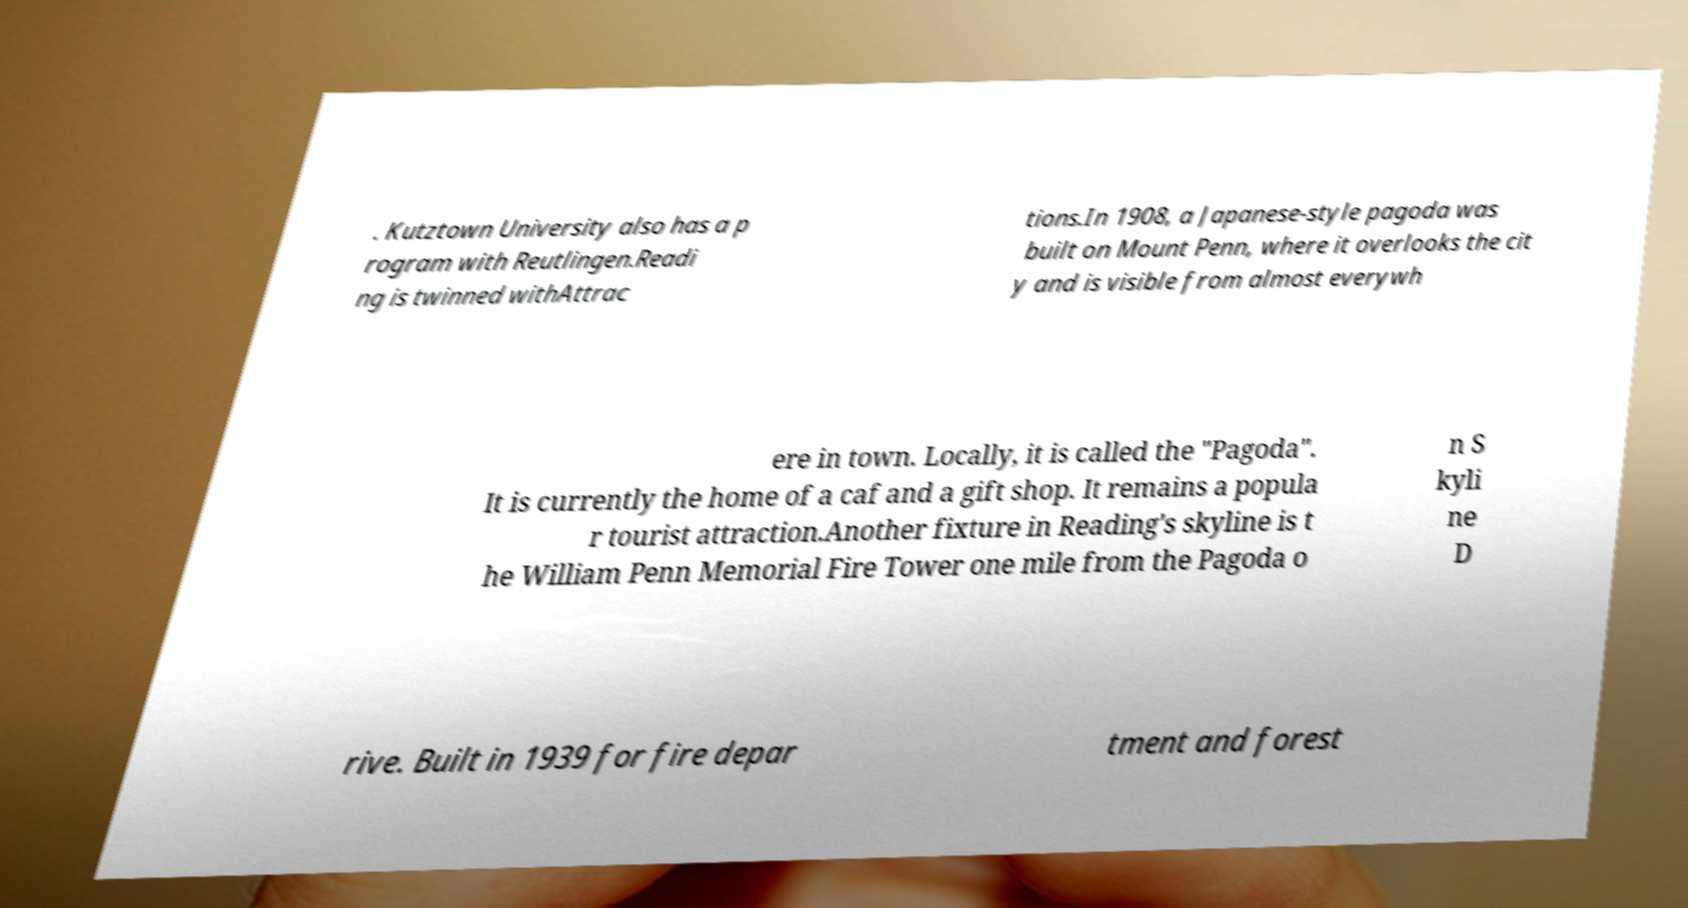For documentation purposes, I need the text within this image transcribed. Could you provide that? . Kutztown University also has a p rogram with Reutlingen.Readi ng is twinned withAttrac tions.In 1908, a Japanese-style pagoda was built on Mount Penn, where it overlooks the cit y and is visible from almost everywh ere in town. Locally, it is called the "Pagoda". It is currently the home of a caf and a gift shop. It remains a popula r tourist attraction.Another fixture in Reading's skyline is t he William Penn Memorial Fire Tower one mile from the Pagoda o n S kyli ne D rive. Built in 1939 for fire depar tment and forest 